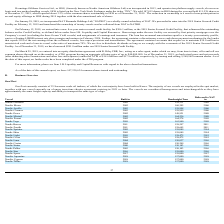From Nordic American Tankers Limited's financial document, What is the the respective years in which Nordic Freedom was built and delivered to NAT? The document shows two values: 2005 and 2005. From the document: "Nordic Freedom 2005 159,331 2005..." Also, What is the the respective years in which Nordic Moon was built and delivered to NAT? The document shows two values: 2002 and 2006. From the document: "Nordic Moon 2002 160,305 2006 Nordic Moon 2002 160,305 2006..." Also, What is the the respective years in which Nordic Apollo was built and delivered to NAT? The document shows two values: 2003 and 2006. From the document: "Nordic Apollo 2003 159,998 2006 Nordic Apollo 2003 159,998 2006..." Also, can you calculate: What is the total weight of Nordic Freedom and Nordic Moon? Based on the calculation: (159,331 + 160,305) , the result is 319636. This is based on the information: "Nordic Moon 2002 160,305 2006 Nordic Freedom 2005 159,331 2005..." The key data points involved are: 159,331, 160,305. Also, can you calculate: What is the average weight of Nordic Freedom and Nordic Moon? To answer this question, I need to perform calculations using the financial data. The calculation is: (159,331 + 160,305)/2 , which equals 159818. This is based on the information: "Nordic Moon 2002 160,305 2006 Nordic Freedom 2005 159,331 2005..." The key data points involved are: 159,331, 160,305. Also, can you calculate: What is the weight of Nordic Moon as a percentage of the weight of Nordic Apollo? Based on the calculation: 160,305/159,998 , the result is 100.19 (percentage). This is based on the information: "Nordic Moon 2002 160,305 2006 Nordic Apollo 2003 159,998 2006..." The key data points involved are: 159,998, 160,305. 